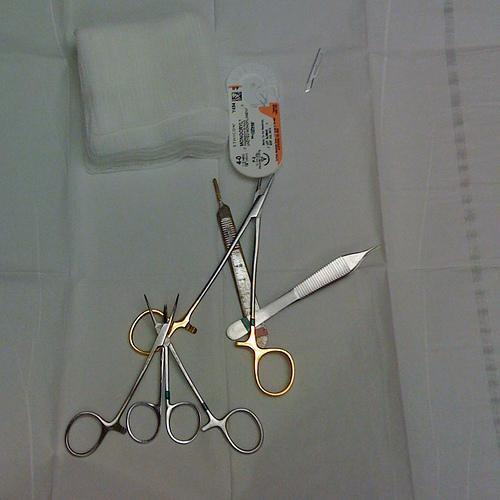How many scissors are there?
Give a very brief answer. 3. How many pairs of scissors in this photo?
Give a very brief answer. 3. How many scissors are in the photo?
Give a very brief answer. 3. How many ovens are here in total?
Give a very brief answer. 0. 